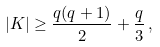<formula> <loc_0><loc_0><loc_500><loc_500>| K | \geq \frac { q ( q + 1 ) } { 2 } + \frac { q } { 3 } \, ,</formula> 